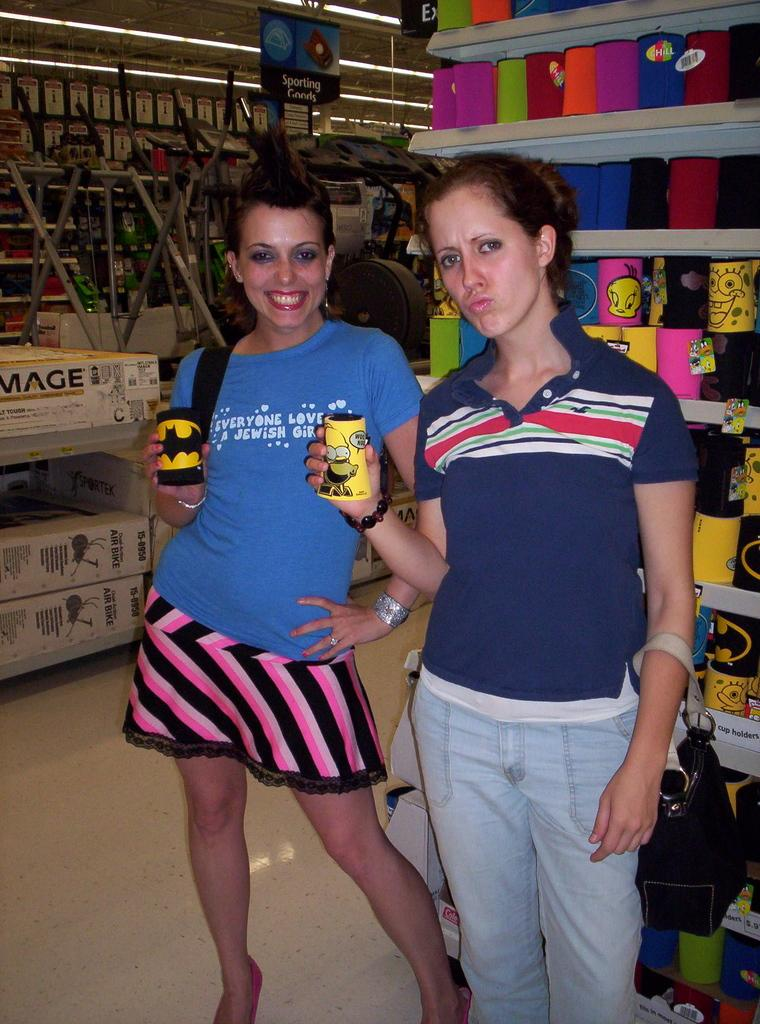<image>
Provide a brief description of the given image. two women, one has a shirt having to do with Jewish religion on it. 